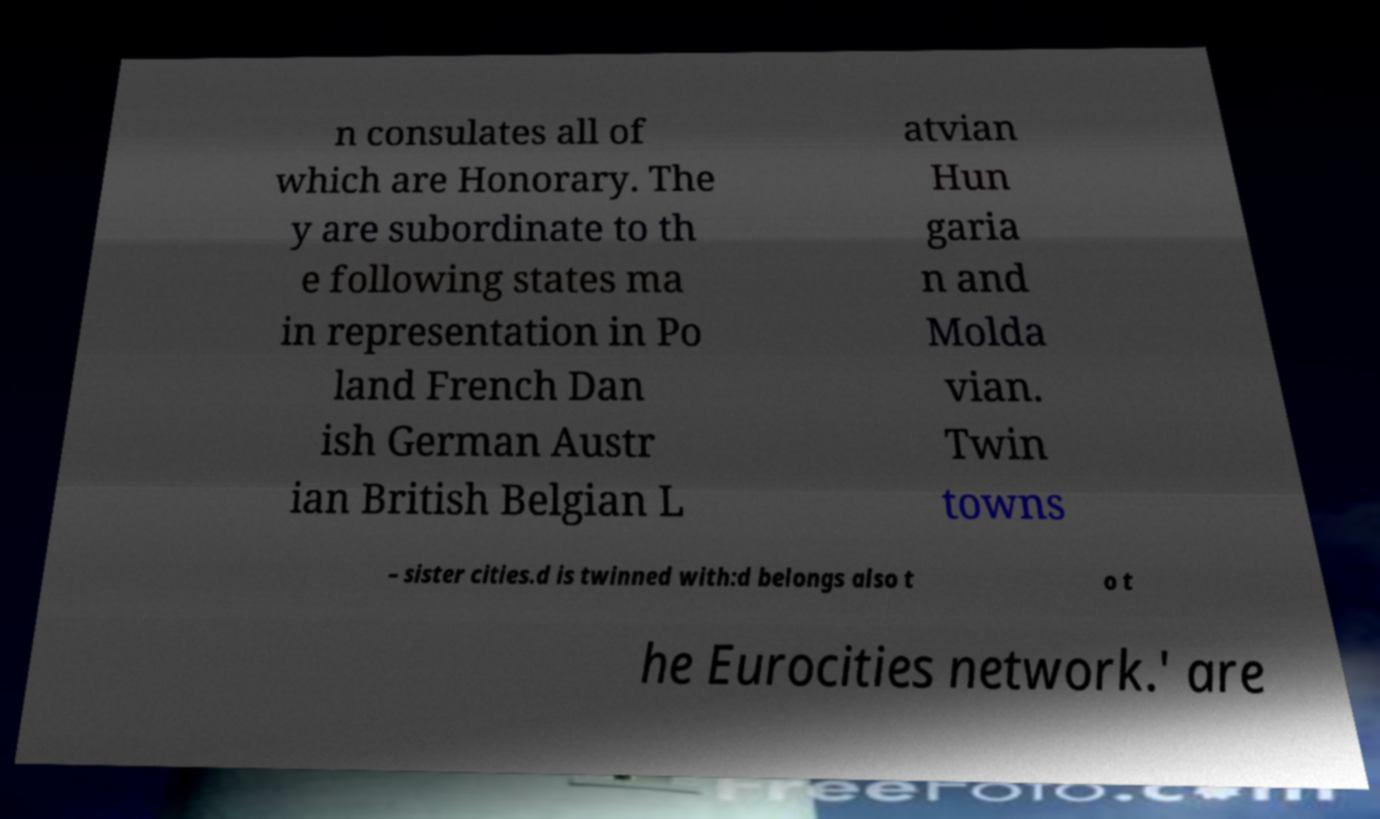Please read and relay the text visible in this image. What does it say? n consulates all of which are Honorary. The y are subordinate to th e following states ma in representation in Po land French Dan ish German Austr ian British Belgian L atvian Hun garia n and Molda vian. Twin towns – sister cities.d is twinned with:d belongs also t o t he Eurocities network.' are 